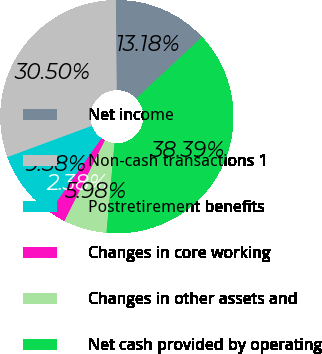Convert chart to OTSL. <chart><loc_0><loc_0><loc_500><loc_500><pie_chart><fcel>Net income<fcel>Non-cash transactions 1<fcel>Postretirement benefits<fcel>Changes in core working<fcel>Changes in other assets and<fcel>Net cash provided by operating<nl><fcel>13.18%<fcel>30.5%<fcel>9.58%<fcel>2.38%<fcel>5.98%<fcel>38.39%<nl></chart> 